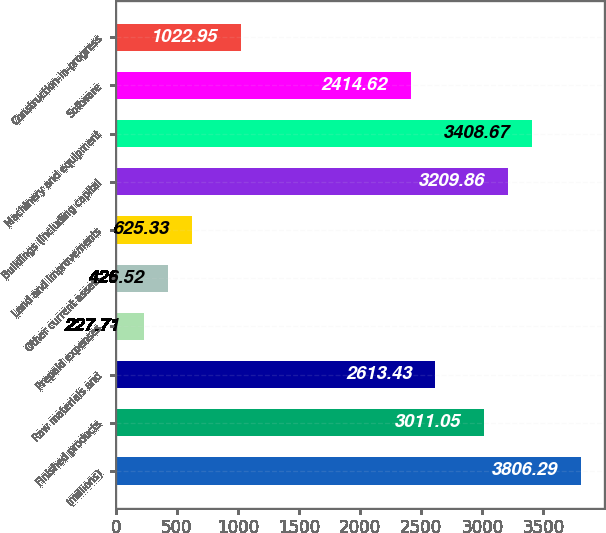Convert chart to OTSL. <chart><loc_0><loc_0><loc_500><loc_500><bar_chart><fcel>(millions)<fcel>Finished products<fcel>Raw materials and<fcel>Prepaid expenses<fcel>Other current assets<fcel>Land and improvements<fcel>Buildings (including capital<fcel>Machinery and equipment<fcel>Software<fcel>Construction-in-progress<nl><fcel>3806.29<fcel>3011.05<fcel>2613.43<fcel>227.71<fcel>426.52<fcel>625.33<fcel>3209.86<fcel>3408.67<fcel>2414.62<fcel>1022.95<nl></chart> 